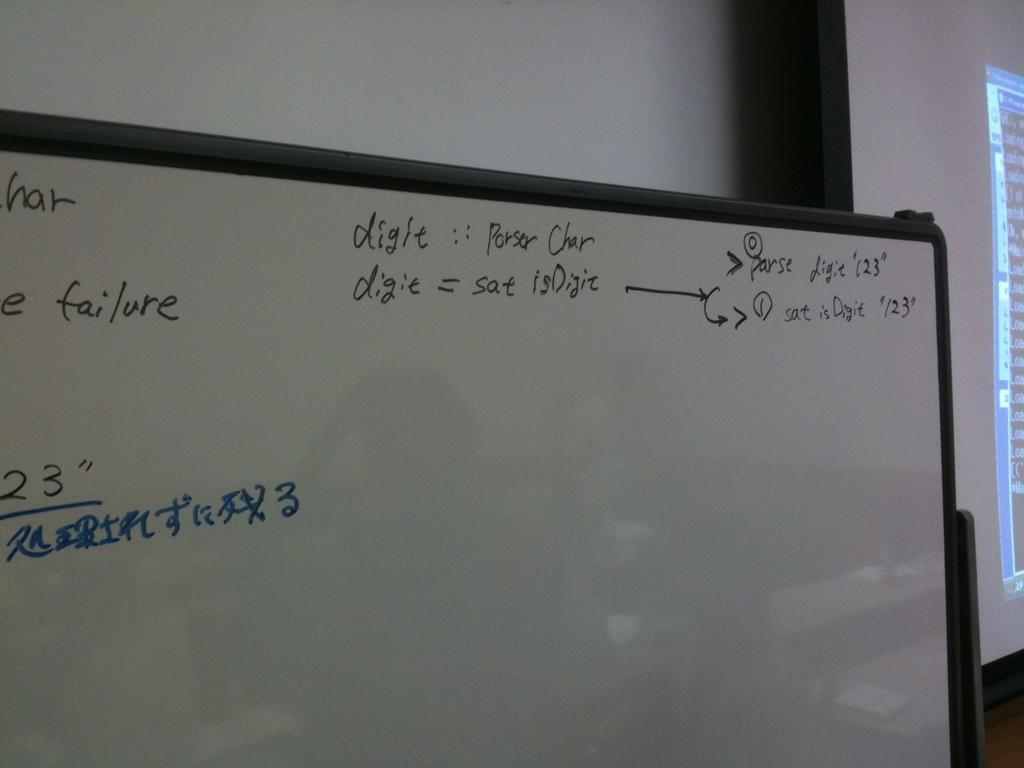<image>
Give a short and clear explanation of the subsequent image. A whiteboard has digit characters and failure conditions written on it. 